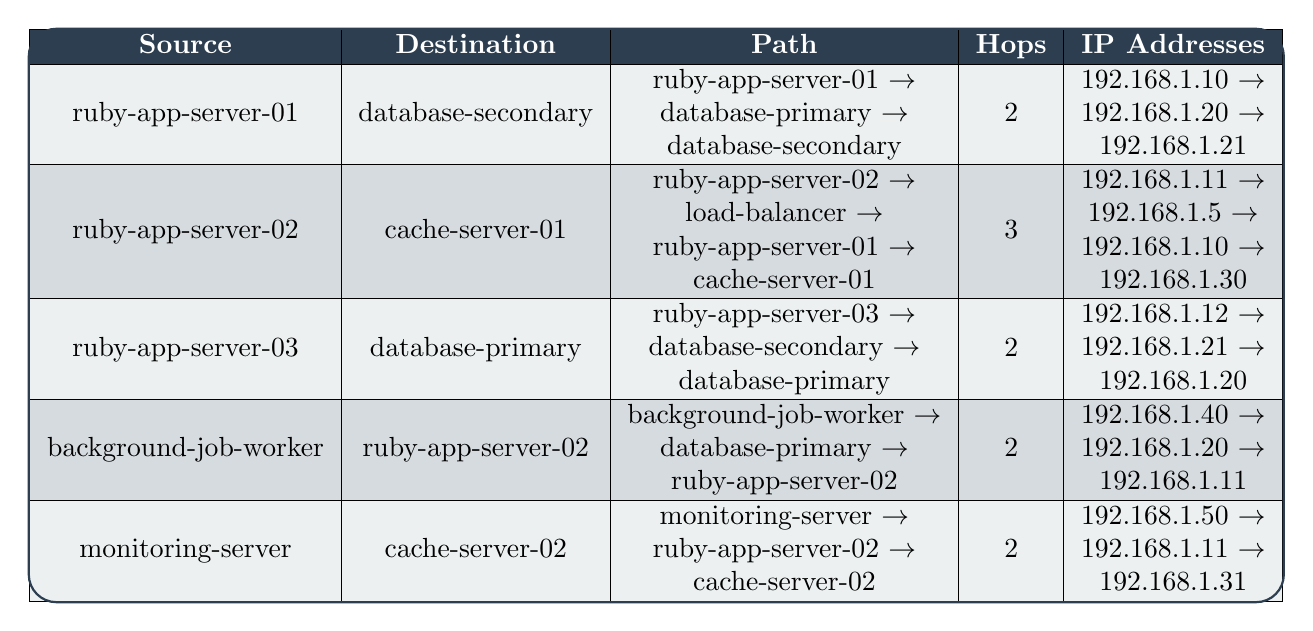What is the IP address of the load balancer? Referring to the table, the load balancer's entry shows that its IP address is listed as 192.168.1.5.
Answer: 192.168.1.5 How many hops are required to connect from ruby-app-server-02 to cache-server-01? The path from ruby-app-server-02 to cache-server-01 is detailed in the table as having 3 hops.
Answer: 3 Which node has the highest number of hops when routing to its destination? By examining the hops for each source-destination pair, the maximum hops noted is 3 (from ruby-app-server-02 to cache-server-01).
Answer: ruby-app-server-02 Is there a direct connection from monitoring-server to database-secondary? The table shows that monitoring-server does not route directly to database-secondary; it routes to ruby-app-server-02 first.
Answer: No How many IP addresses are listed for the route from background-job-worker to ruby-app-server-02? The path contains three nodes: background-job-worker, database-primary, and ruby-app-server-02, which results in three IP addresses (192.168.1.40, 192.168.1.20, 192.168.1.11).
Answer: 3 What is the relationship between ruby-app-server-03 and database-primary? The table indicates that ruby-app-server-03 can reach database-primary through database-secondary in 2 hops.
Answer: Indirect connection Does monitoring-server connect to both cache-server-01 and cache-server-02? According to the table, monitoring-server connects to cache-server-02, but not to cache-server-01 directly. It connects to cache-server-01 indirectly through ruby-app-server-01.
Answer: No If every hop adds a delay of 100ms, what is the total delay for the path from ruby-app-server-01 to database-secondary? The route has 2 hops; thus, the total delay is 2 hops * 100ms/hop = 200ms.
Answer: 200ms Which source node has the same number of hops to its destination as ruby-app-server-03 does to database-primary? Ruby-app-server-01 also has 2 hops to database-secondary, matching ruby-app-server-03's route to database-primary.
Answer: ruby-app-server-01 How does the number of hops from the monitoring-server to cache-server-02 compare to the number of hops from background-job-worker to ruby-app-server-02? Both paths have 2 hops; therefore, the number of hops is the same.
Answer: Same 